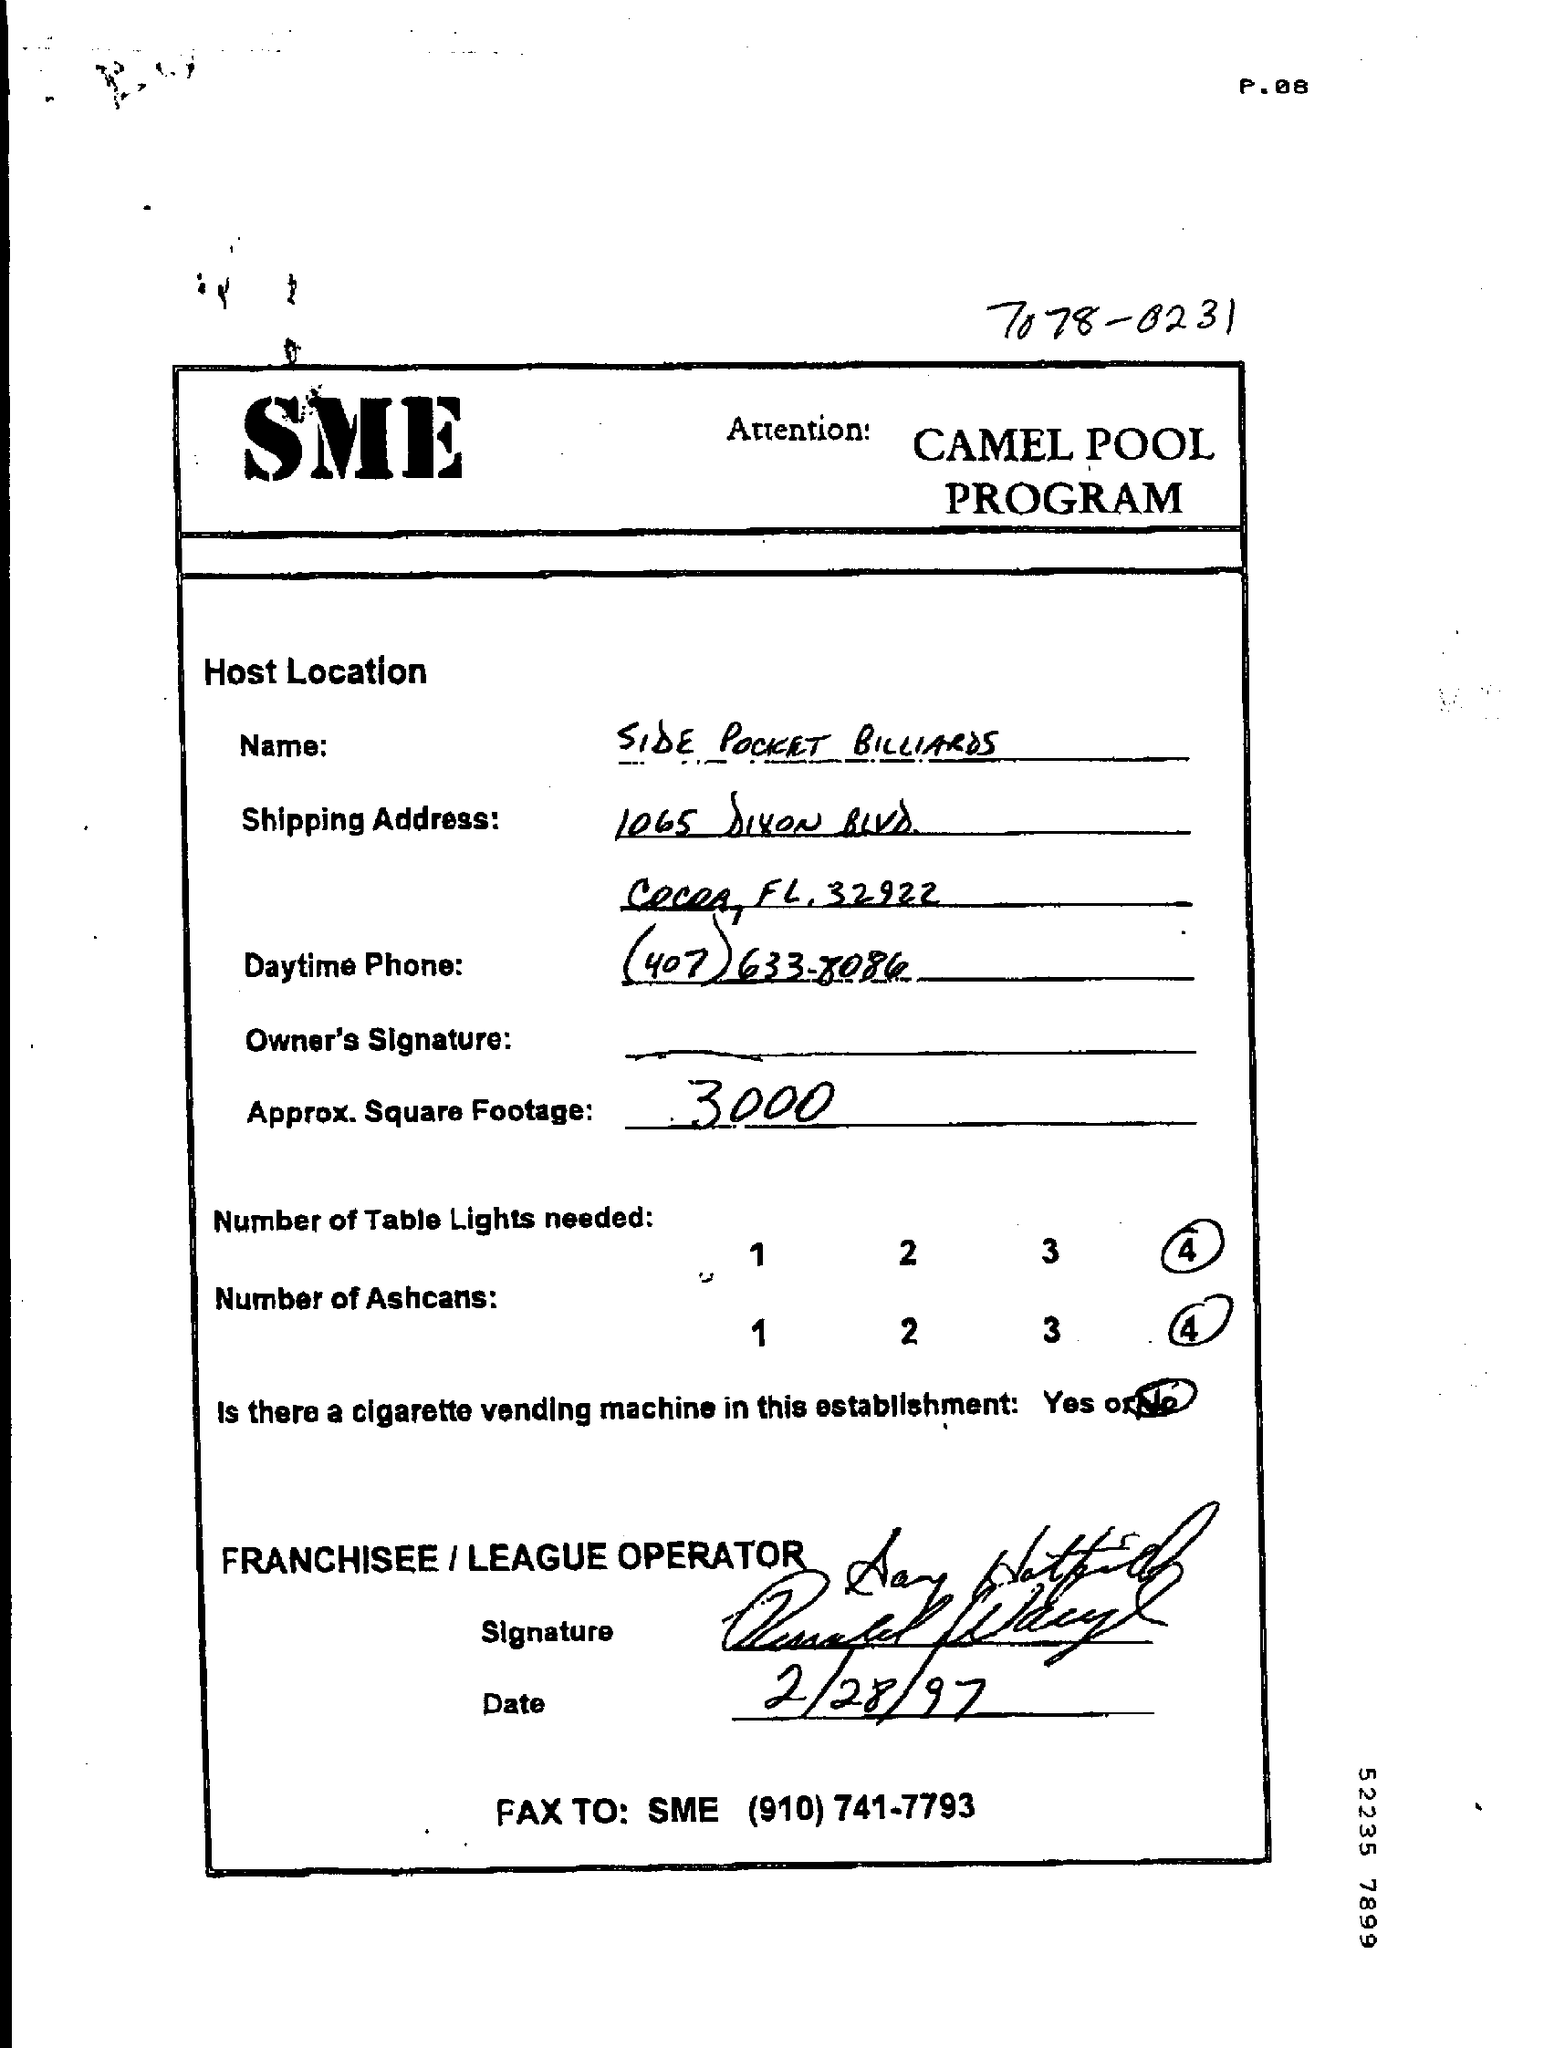What is the approx. square footage value given in the page ?
Your answer should be very brief. 3000. What is the name mentioned in the given page ?
Your answer should be compact. SIDE POCKET BILLIARDS. How many number of table lights needed as mentioned in the given page ?
Provide a short and direct response. 4. How many number of ashcans are needed as mentioned in the given page ?
Make the answer very short. 4. Is there a cigarette vending machine in this establishment ?
Make the answer very short. No. What is the date mentioned in the given page ?
Ensure brevity in your answer.  2/28/97. 